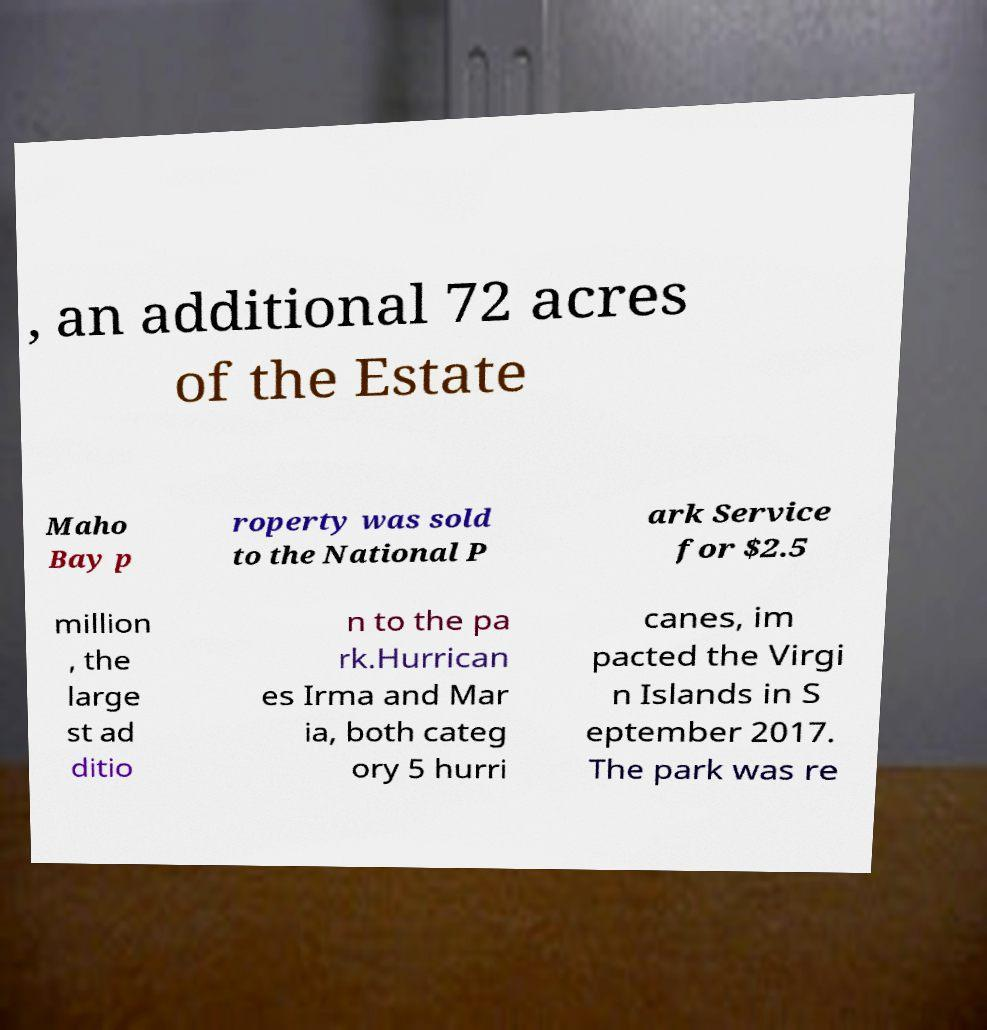I need the written content from this picture converted into text. Can you do that? , an additional 72 acres of the Estate Maho Bay p roperty was sold to the National P ark Service for $2.5 million , the large st ad ditio n to the pa rk.Hurrican es Irma and Mar ia, both categ ory 5 hurri canes, im pacted the Virgi n Islands in S eptember 2017. The park was re 